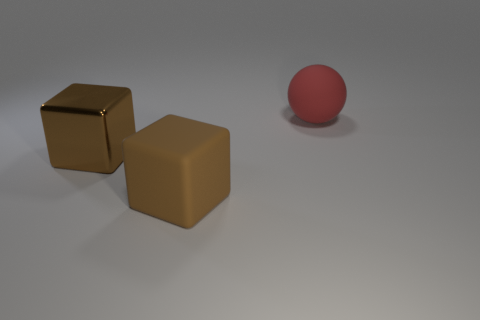Add 2 large red things. How many objects exist? 5 Subtract all spheres. How many objects are left? 2 Add 3 large red matte spheres. How many large red matte spheres are left? 4 Add 1 big rubber things. How many big rubber things exist? 3 Subtract 0 gray cylinders. How many objects are left? 3 Subtract all large brown rubber blocks. Subtract all brown metallic things. How many objects are left? 1 